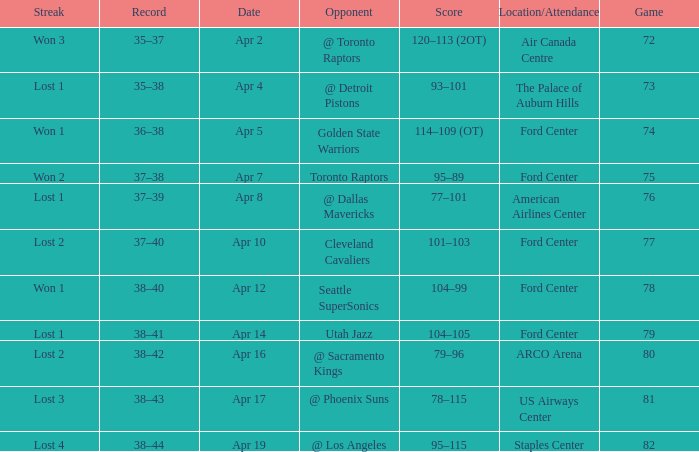What was the location when the opponent was Seattle Supersonics? Ford Center. 